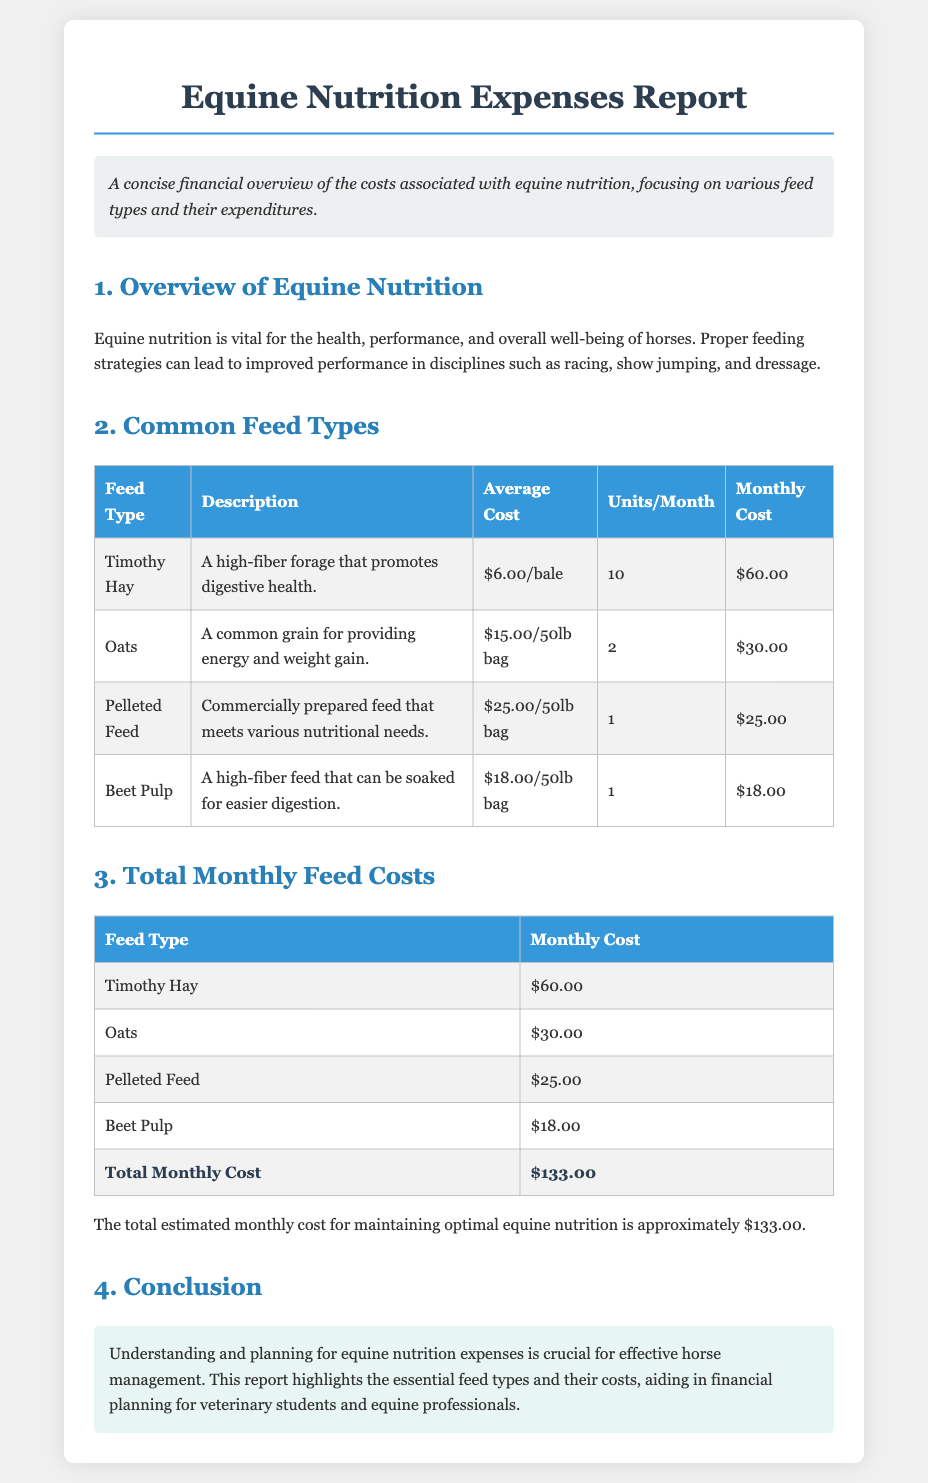What is the average cost of Timothy Hay? Timothy Hay is listed at an average cost of $6.00 per bale in the document.
Answer: $6.00/bale How many units of Oats are used per month? The document specifies that 2 units of Oats are used per month.
Answer: 2 What is the total monthly cost for Pelleted Feed? The document indicates that the monthly cost for Pelleted Feed is $25.00.
Answer: $25.00 Which feed type has the highest average cost? Comparing the average costs in the document, Pelleted Feed has the highest cost at $25.00 per bag.
Answer: Pelleted Feed What is the total estimated monthly cost for maintaining equine nutrition? The total estimated monthly cost for equine nutrition, as stated in the document, is $133.00.
Answer: $133.00 What is the purpose of equine nutrition mentioned in the document? The document states that equine nutrition is vital for health, performance, and overall well-being.
Answer: Health, performance, overall well-being Which feed type promotes digestive health? Timothy Hay is described as a feed type that promotes digestive health.
Answer: Timothy Hay How many feed types are detailed in the report? The report details four different feed types in its cost analysis.
Answer: Four 